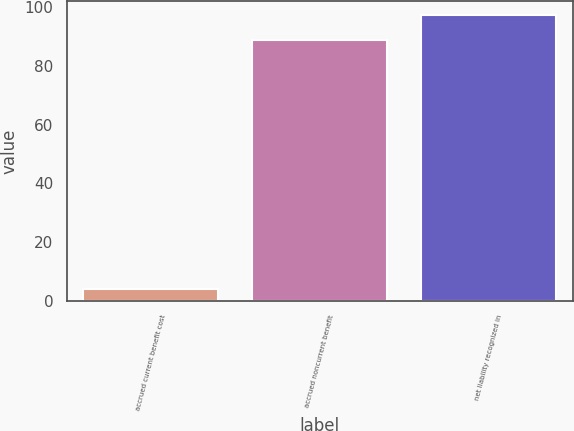Convert chart. <chart><loc_0><loc_0><loc_500><loc_500><bar_chart><fcel>accrued current benefit cost<fcel>accrued noncurrent benefit<fcel>net liability recognized in<nl><fcel>4<fcel>88.7<fcel>97.22<nl></chart> 